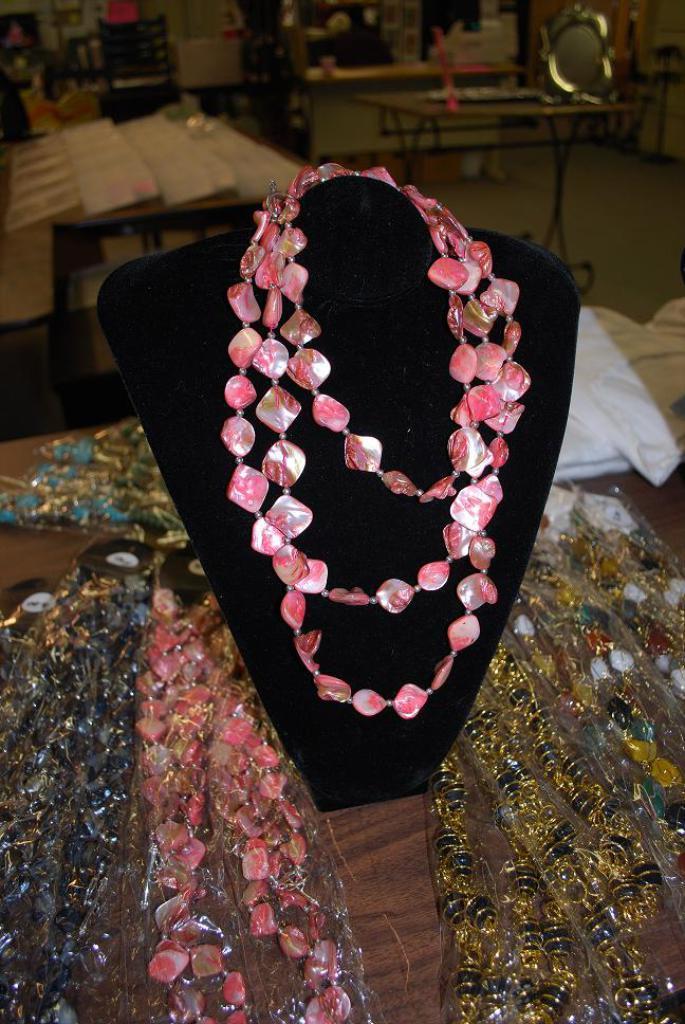Describe this image in one or two sentences. In this image in the center there is a necklace, and at the bottom there is a table. On the table there are some chains and plastic covers, in the background there are some tables, mirror chairs and some boards. 